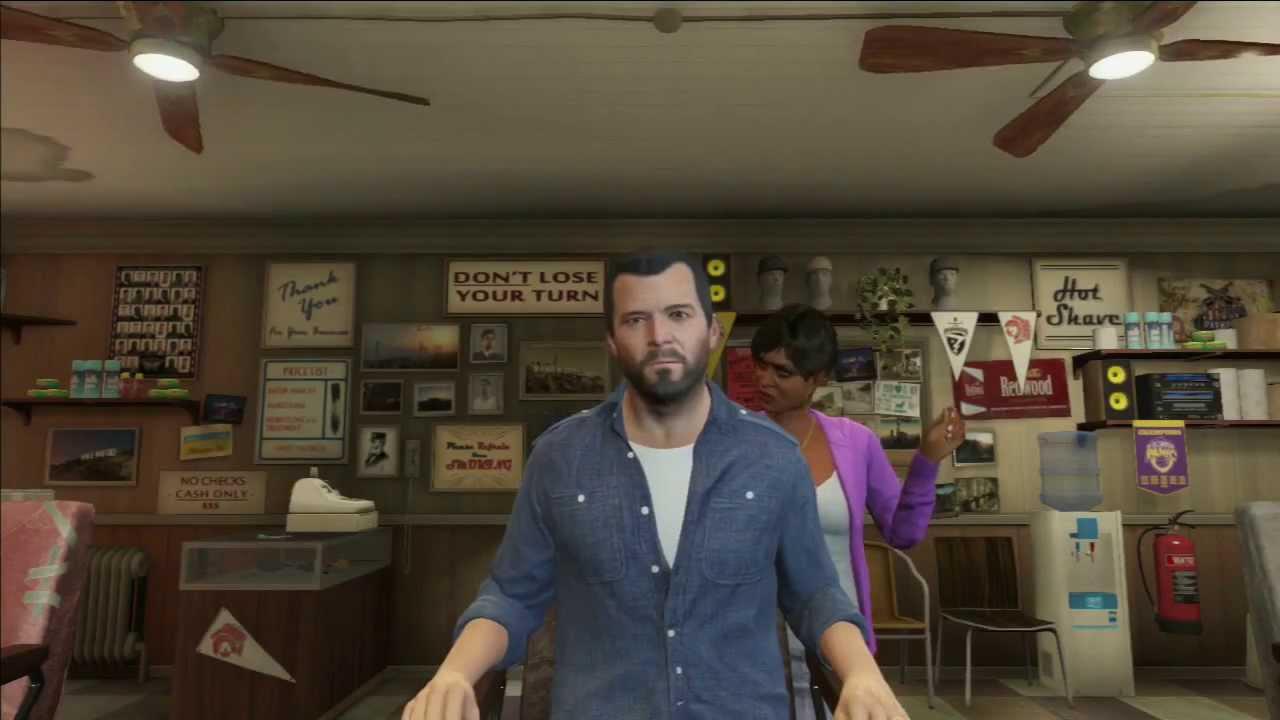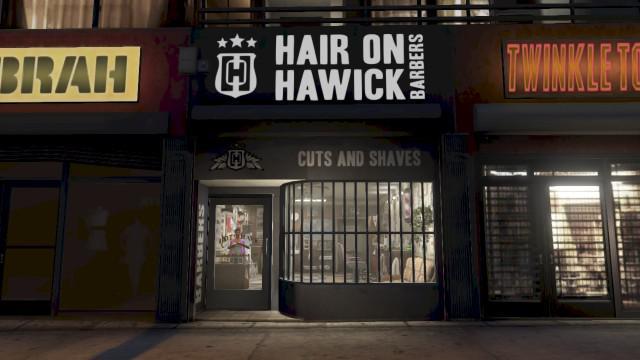The first image is the image on the left, the second image is the image on the right. Evaluate the accuracy of this statement regarding the images: "One picture contains a man with short hair and facial hair getting his hair cut by an African American woman.". Is it true? Answer yes or no. Yes. 